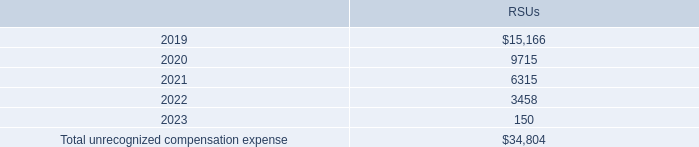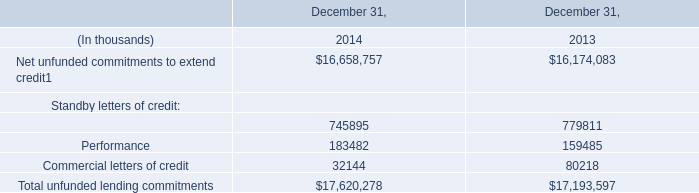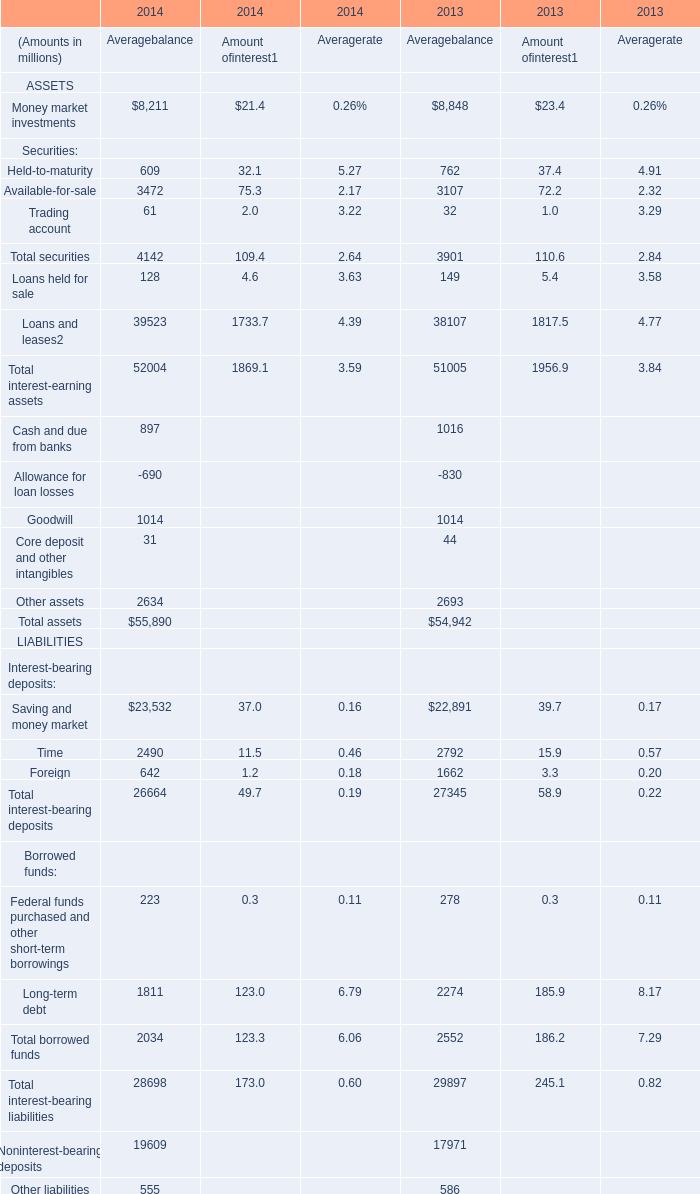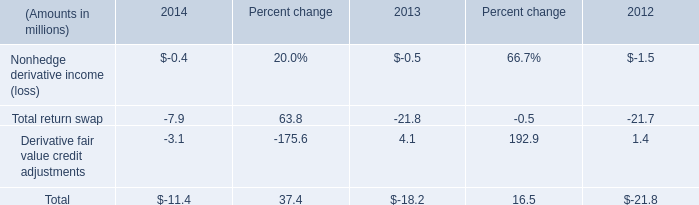As As the chart 2 shows,in what year is the amount of the Average balance for Other assets higher? 
Answer: 2013. 